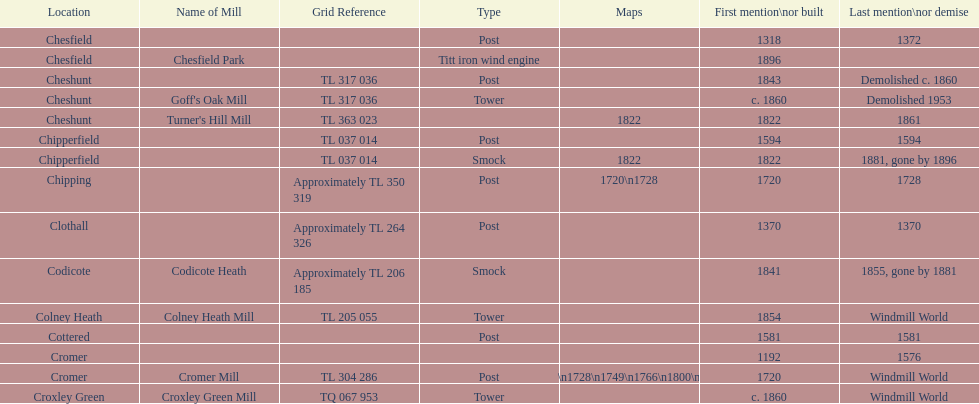What location has the most maps? Cromer. 